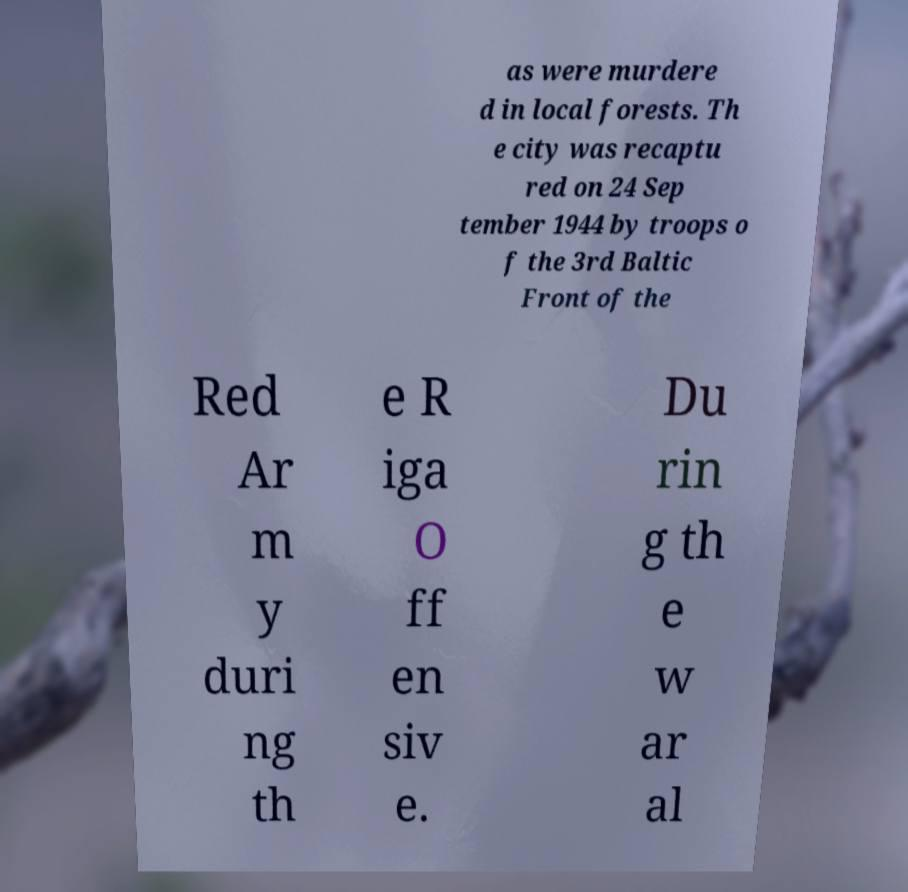There's text embedded in this image that I need extracted. Can you transcribe it verbatim? as were murdere d in local forests. Th e city was recaptu red on 24 Sep tember 1944 by troops o f the 3rd Baltic Front of the Red Ar m y duri ng th e R iga O ff en siv e. Du rin g th e w ar al 